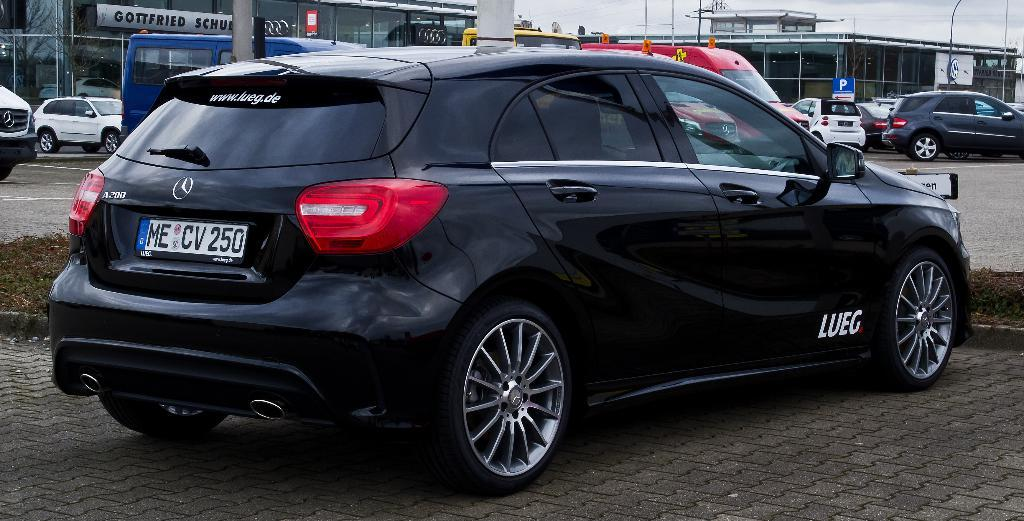What type of vehicles can be seen in the image? There are many cars in the image. How many vehicles are present in the image? There are few vehicles in the image. Where are the cars and vehicles located? The cars and vehicles are parked on a surface. What can be seen in the background of the image? There are two buildings visible behind the vehicles. What type of trousers are the cars wearing in the image? Cars do not wear trousers, as they are inanimate objects. 